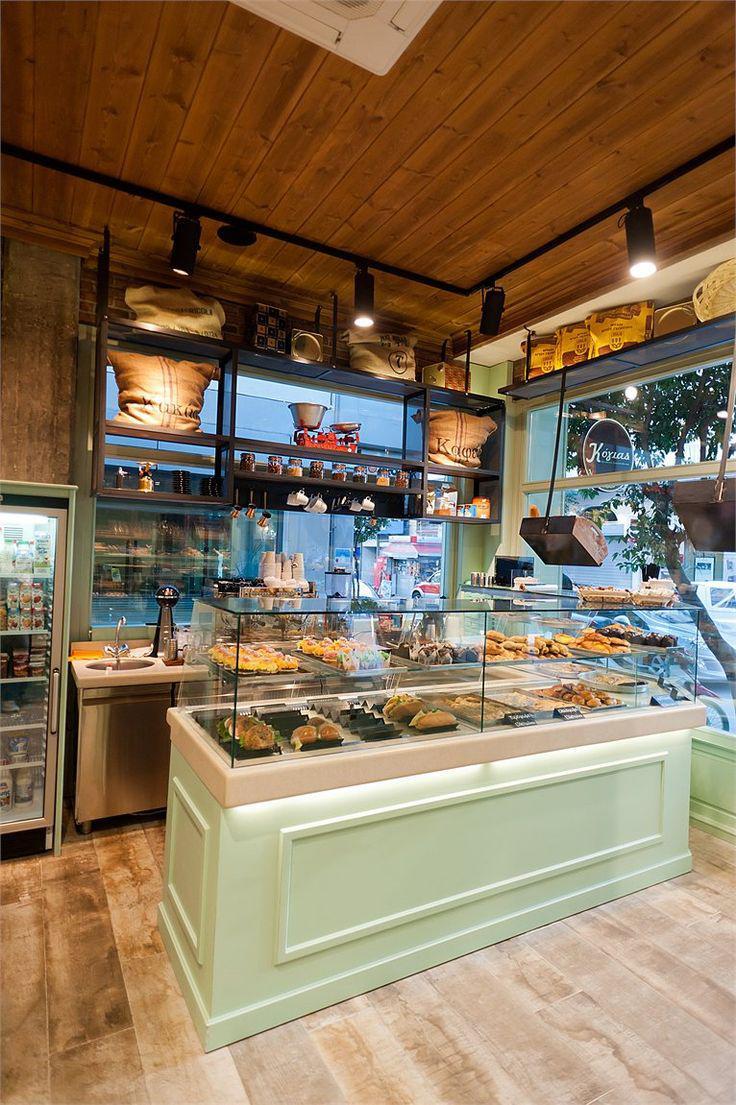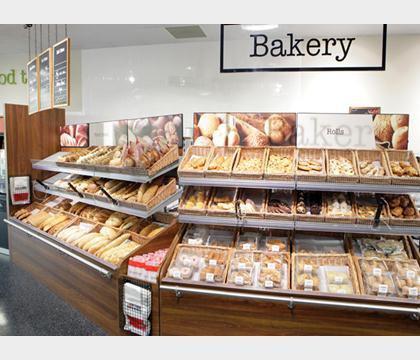The first image is the image on the left, the second image is the image on the right. Considering the images on both sides, is "Bread that is not in any individual packaging is displayed for sale." valid? Answer yes or no. Yes. The first image is the image on the left, the second image is the image on the right. Considering the images on both sides, is "the bakery sign is on the wall" valid? Answer yes or no. Yes. 